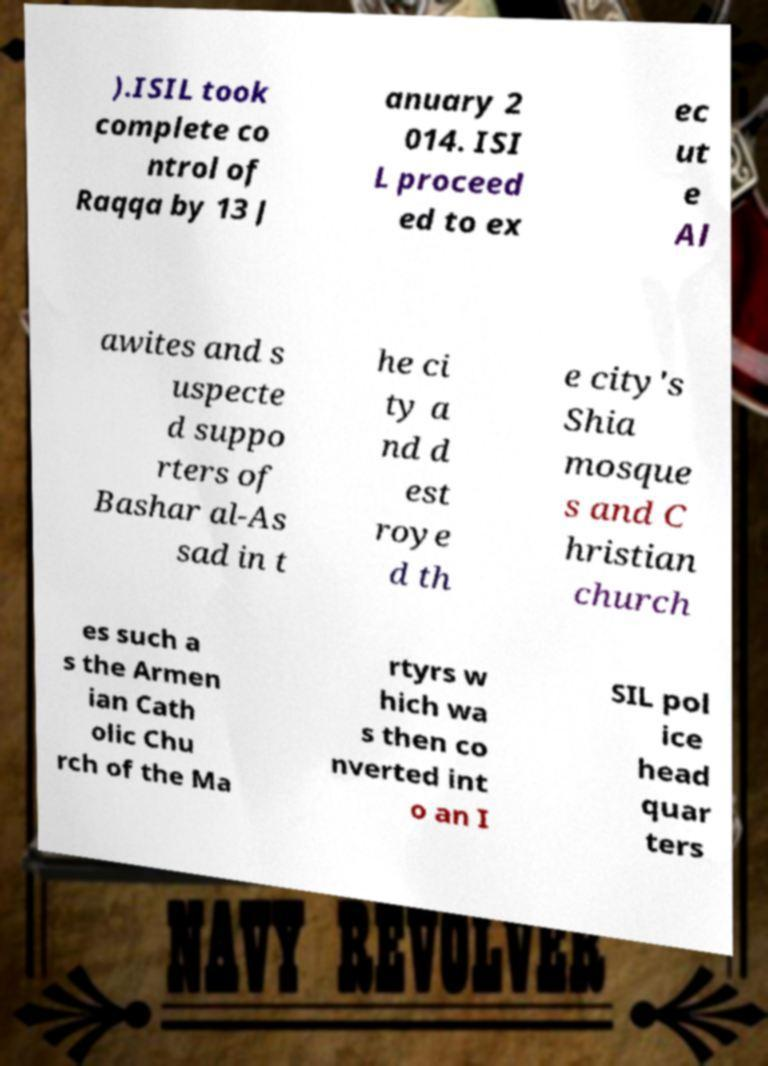Please identify and transcribe the text found in this image. ).ISIL took complete co ntrol of Raqqa by 13 J anuary 2 014. ISI L proceed ed to ex ec ut e Al awites and s uspecte d suppo rters of Bashar al-As sad in t he ci ty a nd d est roye d th e city's Shia mosque s and C hristian church es such a s the Armen ian Cath olic Chu rch of the Ma rtyrs w hich wa s then co nverted int o an I SIL pol ice head quar ters 